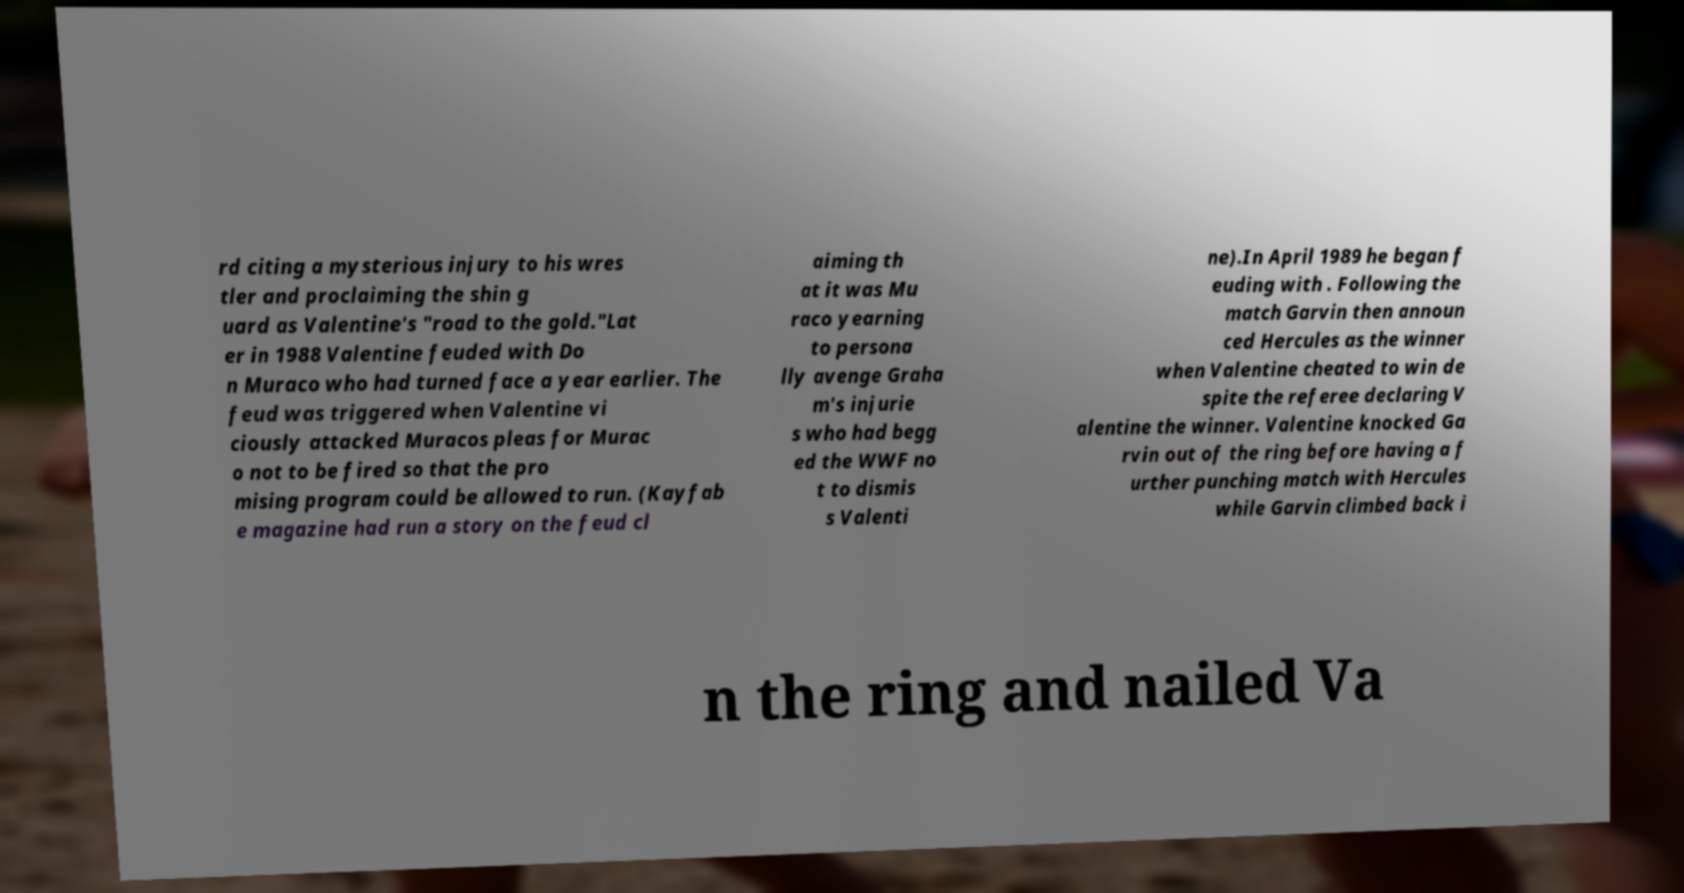Can you accurately transcribe the text from the provided image for me? rd citing a mysterious injury to his wres tler and proclaiming the shin g uard as Valentine's "road to the gold."Lat er in 1988 Valentine feuded with Do n Muraco who had turned face a year earlier. The feud was triggered when Valentine vi ciously attacked Muracos pleas for Murac o not to be fired so that the pro mising program could be allowed to run. (Kayfab e magazine had run a story on the feud cl aiming th at it was Mu raco yearning to persona lly avenge Graha m's injurie s who had begg ed the WWF no t to dismis s Valenti ne).In April 1989 he began f euding with . Following the match Garvin then announ ced Hercules as the winner when Valentine cheated to win de spite the referee declaring V alentine the winner. Valentine knocked Ga rvin out of the ring before having a f urther punching match with Hercules while Garvin climbed back i n the ring and nailed Va 